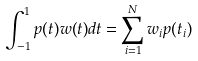<formula> <loc_0><loc_0><loc_500><loc_500>\int _ { - 1 } ^ { 1 } p ( t ) w ( t ) d t = \sum _ { i = 1 } ^ { N } w _ { i } p ( t _ { i } )</formula> 